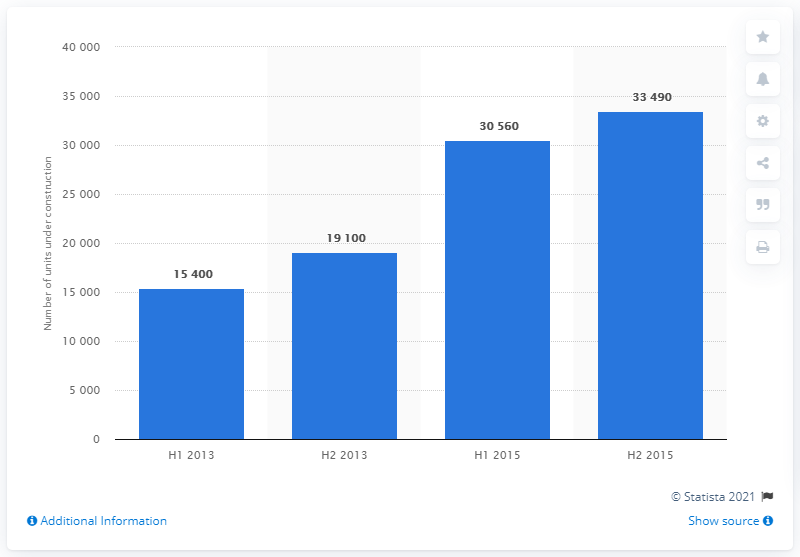Indicate a few pertinent items in this graphic. There were 33,490 residential property units under construction in the London market during the second half of 2015. 